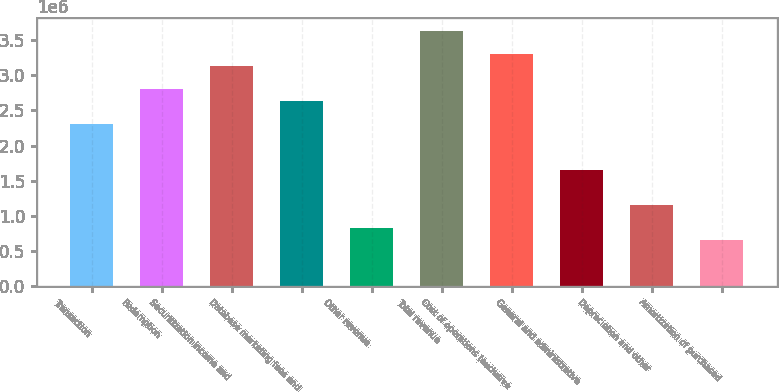<chart> <loc_0><loc_0><loc_500><loc_500><bar_chart><fcel>Transaction<fcel>Redemption<fcel>Securitization income and<fcel>Database marketing fees and<fcel>Other revenue<fcel>Total revenue<fcel>Cost of operations (exclusive<fcel>General and administrative<fcel>Depreciation and other<fcel>Amortization of purchased<nl><fcel>2.31077e+06<fcel>2.80593e+06<fcel>3.13604e+06<fcel>2.64088e+06<fcel>825275<fcel>3.63121e+06<fcel>3.3011e+06<fcel>1.65055e+06<fcel>1.15538e+06<fcel>660220<nl></chart> 